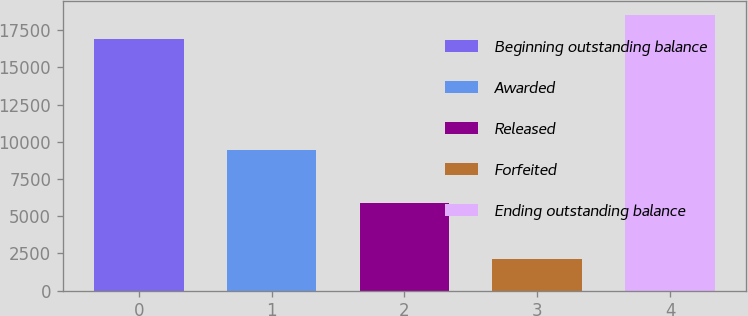Convert chart. <chart><loc_0><loc_0><loc_500><loc_500><bar_chart><fcel>Beginning outstanding balance<fcel>Awarded<fcel>Released<fcel>Forfeited<fcel>Ending outstanding balance<nl><fcel>16871<fcel>9431<fcel>5854<fcel>2147<fcel>18497.8<nl></chart> 